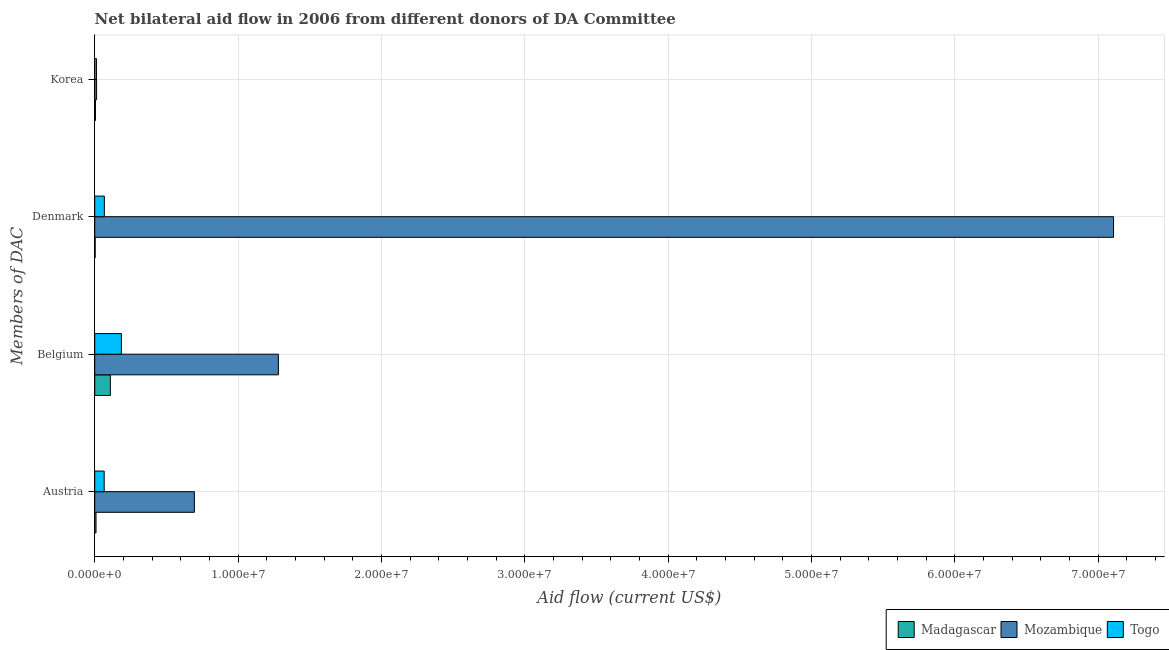How many groups of bars are there?
Offer a terse response. 4. Are the number of bars per tick equal to the number of legend labels?
Offer a terse response. Yes. Are the number of bars on each tick of the Y-axis equal?
Keep it short and to the point. Yes. How many bars are there on the 3rd tick from the bottom?
Offer a terse response. 3. What is the label of the 3rd group of bars from the top?
Make the answer very short. Belgium. What is the amount of aid given by belgium in Togo?
Give a very brief answer. 1.86e+06. Across all countries, what is the maximum amount of aid given by denmark?
Keep it short and to the point. 7.11e+07. Across all countries, what is the minimum amount of aid given by austria?
Keep it short and to the point. 9.00e+04. In which country was the amount of aid given by austria maximum?
Offer a terse response. Mozambique. In which country was the amount of aid given by belgium minimum?
Provide a succinct answer. Madagascar. What is the total amount of aid given by belgium in the graph?
Provide a short and direct response. 1.58e+07. What is the difference between the amount of aid given by belgium in Togo and that in Mozambique?
Ensure brevity in your answer.  -1.10e+07. What is the difference between the amount of aid given by austria in Togo and the amount of aid given by korea in Mozambique?
Your response must be concise. 5.30e+05. What is the average amount of aid given by belgium per country?
Provide a short and direct response. 5.25e+06. What is the difference between the amount of aid given by denmark and amount of aid given by austria in Togo?
Make the answer very short. 10000. In how many countries, is the amount of aid given by korea greater than 22000000 US$?
Make the answer very short. 0. What is the ratio of the amount of aid given by austria in Mozambique to that in Madagascar?
Your answer should be very brief. 77.22. Is the amount of aid given by austria in Mozambique less than that in Togo?
Provide a short and direct response. No. Is the difference between the amount of aid given by korea in Mozambique and Madagascar greater than the difference between the amount of aid given by belgium in Mozambique and Madagascar?
Offer a very short reply. No. What is the difference between the highest and the second highest amount of aid given by belgium?
Your response must be concise. 1.10e+07. What is the difference between the highest and the lowest amount of aid given by belgium?
Give a very brief answer. 1.17e+07. What does the 2nd bar from the top in Austria represents?
Your answer should be very brief. Mozambique. What does the 3rd bar from the bottom in Korea represents?
Give a very brief answer. Togo. Is it the case that in every country, the sum of the amount of aid given by austria and amount of aid given by belgium is greater than the amount of aid given by denmark?
Ensure brevity in your answer.  No. How many bars are there?
Make the answer very short. 12. How many countries are there in the graph?
Give a very brief answer. 3. What is the difference between two consecutive major ticks on the X-axis?
Give a very brief answer. 1.00e+07. How many legend labels are there?
Provide a short and direct response. 3. How are the legend labels stacked?
Make the answer very short. Horizontal. What is the title of the graph?
Your response must be concise. Net bilateral aid flow in 2006 from different donors of DA Committee. What is the label or title of the Y-axis?
Your answer should be compact. Members of DAC. What is the Aid flow (current US$) of Mozambique in Austria?
Make the answer very short. 6.95e+06. What is the Aid flow (current US$) in Madagascar in Belgium?
Provide a succinct answer. 1.09e+06. What is the Aid flow (current US$) of Mozambique in Belgium?
Your response must be concise. 1.28e+07. What is the Aid flow (current US$) of Togo in Belgium?
Keep it short and to the point. 1.86e+06. What is the Aid flow (current US$) in Mozambique in Denmark?
Give a very brief answer. 7.11e+07. What is the Aid flow (current US$) in Togo in Denmark?
Make the answer very short. 6.70e+05. What is the Aid flow (current US$) in Madagascar in Korea?
Give a very brief answer. 5.00e+04. What is the Aid flow (current US$) in Mozambique in Korea?
Give a very brief answer. 1.30e+05. What is the Aid flow (current US$) of Togo in Korea?
Offer a very short reply. 1.20e+05. Across all Members of DAC, what is the maximum Aid flow (current US$) in Madagascar?
Offer a very short reply. 1.09e+06. Across all Members of DAC, what is the maximum Aid flow (current US$) of Mozambique?
Provide a short and direct response. 7.11e+07. Across all Members of DAC, what is the maximum Aid flow (current US$) of Togo?
Provide a succinct answer. 1.86e+06. Across all Members of DAC, what is the minimum Aid flow (current US$) of Madagascar?
Provide a short and direct response. 3.00e+04. Across all Members of DAC, what is the minimum Aid flow (current US$) of Mozambique?
Ensure brevity in your answer.  1.30e+05. What is the total Aid flow (current US$) of Madagascar in the graph?
Offer a very short reply. 1.26e+06. What is the total Aid flow (current US$) in Mozambique in the graph?
Provide a short and direct response. 9.10e+07. What is the total Aid flow (current US$) in Togo in the graph?
Offer a terse response. 3.31e+06. What is the difference between the Aid flow (current US$) in Mozambique in Austria and that in Belgium?
Give a very brief answer. -5.86e+06. What is the difference between the Aid flow (current US$) in Togo in Austria and that in Belgium?
Provide a succinct answer. -1.20e+06. What is the difference between the Aid flow (current US$) of Madagascar in Austria and that in Denmark?
Your answer should be very brief. 6.00e+04. What is the difference between the Aid flow (current US$) of Mozambique in Austria and that in Denmark?
Your answer should be compact. -6.41e+07. What is the difference between the Aid flow (current US$) in Togo in Austria and that in Denmark?
Provide a succinct answer. -10000. What is the difference between the Aid flow (current US$) of Mozambique in Austria and that in Korea?
Your answer should be compact. 6.82e+06. What is the difference between the Aid flow (current US$) of Togo in Austria and that in Korea?
Provide a short and direct response. 5.40e+05. What is the difference between the Aid flow (current US$) in Madagascar in Belgium and that in Denmark?
Your answer should be compact. 1.06e+06. What is the difference between the Aid flow (current US$) of Mozambique in Belgium and that in Denmark?
Your answer should be compact. -5.83e+07. What is the difference between the Aid flow (current US$) in Togo in Belgium and that in Denmark?
Offer a terse response. 1.19e+06. What is the difference between the Aid flow (current US$) in Madagascar in Belgium and that in Korea?
Ensure brevity in your answer.  1.04e+06. What is the difference between the Aid flow (current US$) in Mozambique in Belgium and that in Korea?
Offer a very short reply. 1.27e+07. What is the difference between the Aid flow (current US$) in Togo in Belgium and that in Korea?
Provide a short and direct response. 1.74e+06. What is the difference between the Aid flow (current US$) of Madagascar in Denmark and that in Korea?
Provide a succinct answer. -2.00e+04. What is the difference between the Aid flow (current US$) of Mozambique in Denmark and that in Korea?
Provide a short and direct response. 7.09e+07. What is the difference between the Aid flow (current US$) of Madagascar in Austria and the Aid flow (current US$) of Mozambique in Belgium?
Keep it short and to the point. -1.27e+07. What is the difference between the Aid flow (current US$) in Madagascar in Austria and the Aid flow (current US$) in Togo in Belgium?
Keep it short and to the point. -1.77e+06. What is the difference between the Aid flow (current US$) in Mozambique in Austria and the Aid flow (current US$) in Togo in Belgium?
Provide a succinct answer. 5.09e+06. What is the difference between the Aid flow (current US$) of Madagascar in Austria and the Aid flow (current US$) of Mozambique in Denmark?
Make the answer very short. -7.10e+07. What is the difference between the Aid flow (current US$) of Madagascar in Austria and the Aid flow (current US$) of Togo in Denmark?
Ensure brevity in your answer.  -5.80e+05. What is the difference between the Aid flow (current US$) in Mozambique in Austria and the Aid flow (current US$) in Togo in Denmark?
Make the answer very short. 6.28e+06. What is the difference between the Aid flow (current US$) of Mozambique in Austria and the Aid flow (current US$) of Togo in Korea?
Give a very brief answer. 6.83e+06. What is the difference between the Aid flow (current US$) in Madagascar in Belgium and the Aid flow (current US$) in Mozambique in Denmark?
Give a very brief answer. -7.00e+07. What is the difference between the Aid flow (current US$) of Mozambique in Belgium and the Aid flow (current US$) of Togo in Denmark?
Keep it short and to the point. 1.21e+07. What is the difference between the Aid flow (current US$) of Madagascar in Belgium and the Aid flow (current US$) of Mozambique in Korea?
Offer a terse response. 9.60e+05. What is the difference between the Aid flow (current US$) of Madagascar in Belgium and the Aid flow (current US$) of Togo in Korea?
Keep it short and to the point. 9.70e+05. What is the difference between the Aid flow (current US$) of Mozambique in Belgium and the Aid flow (current US$) of Togo in Korea?
Make the answer very short. 1.27e+07. What is the difference between the Aid flow (current US$) in Madagascar in Denmark and the Aid flow (current US$) in Mozambique in Korea?
Make the answer very short. -1.00e+05. What is the difference between the Aid flow (current US$) of Mozambique in Denmark and the Aid flow (current US$) of Togo in Korea?
Give a very brief answer. 7.10e+07. What is the average Aid flow (current US$) of Madagascar per Members of DAC?
Provide a short and direct response. 3.15e+05. What is the average Aid flow (current US$) in Mozambique per Members of DAC?
Offer a terse response. 2.27e+07. What is the average Aid flow (current US$) of Togo per Members of DAC?
Offer a very short reply. 8.28e+05. What is the difference between the Aid flow (current US$) of Madagascar and Aid flow (current US$) of Mozambique in Austria?
Offer a very short reply. -6.86e+06. What is the difference between the Aid flow (current US$) of Madagascar and Aid flow (current US$) of Togo in Austria?
Your answer should be compact. -5.70e+05. What is the difference between the Aid flow (current US$) of Mozambique and Aid flow (current US$) of Togo in Austria?
Offer a very short reply. 6.29e+06. What is the difference between the Aid flow (current US$) of Madagascar and Aid flow (current US$) of Mozambique in Belgium?
Keep it short and to the point. -1.17e+07. What is the difference between the Aid flow (current US$) in Madagascar and Aid flow (current US$) in Togo in Belgium?
Give a very brief answer. -7.70e+05. What is the difference between the Aid flow (current US$) in Mozambique and Aid flow (current US$) in Togo in Belgium?
Your answer should be very brief. 1.10e+07. What is the difference between the Aid flow (current US$) in Madagascar and Aid flow (current US$) in Mozambique in Denmark?
Offer a terse response. -7.10e+07. What is the difference between the Aid flow (current US$) of Madagascar and Aid flow (current US$) of Togo in Denmark?
Offer a very short reply. -6.40e+05. What is the difference between the Aid flow (current US$) in Mozambique and Aid flow (current US$) in Togo in Denmark?
Provide a short and direct response. 7.04e+07. What is the difference between the Aid flow (current US$) in Madagascar and Aid flow (current US$) in Togo in Korea?
Provide a succinct answer. -7.00e+04. What is the difference between the Aid flow (current US$) in Mozambique and Aid flow (current US$) in Togo in Korea?
Your response must be concise. 10000. What is the ratio of the Aid flow (current US$) of Madagascar in Austria to that in Belgium?
Provide a succinct answer. 0.08. What is the ratio of the Aid flow (current US$) of Mozambique in Austria to that in Belgium?
Provide a succinct answer. 0.54. What is the ratio of the Aid flow (current US$) in Togo in Austria to that in Belgium?
Provide a short and direct response. 0.35. What is the ratio of the Aid flow (current US$) of Madagascar in Austria to that in Denmark?
Ensure brevity in your answer.  3. What is the ratio of the Aid flow (current US$) in Mozambique in Austria to that in Denmark?
Your response must be concise. 0.1. What is the ratio of the Aid flow (current US$) of Togo in Austria to that in Denmark?
Offer a terse response. 0.99. What is the ratio of the Aid flow (current US$) of Mozambique in Austria to that in Korea?
Your answer should be very brief. 53.46. What is the ratio of the Aid flow (current US$) of Togo in Austria to that in Korea?
Provide a succinct answer. 5.5. What is the ratio of the Aid flow (current US$) of Madagascar in Belgium to that in Denmark?
Keep it short and to the point. 36.33. What is the ratio of the Aid flow (current US$) of Mozambique in Belgium to that in Denmark?
Provide a succinct answer. 0.18. What is the ratio of the Aid flow (current US$) in Togo in Belgium to that in Denmark?
Provide a succinct answer. 2.78. What is the ratio of the Aid flow (current US$) in Madagascar in Belgium to that in Korea?
Your response must be concise. 21.8. What is the ratio of the Aid flow (current US$) in Mozambique in Belgium to that in Korea?
Keep it short and to the point. 98.54. What is the ratio of the Aid flow (current US$) of Madagascar in Denmark to that in Korea?
Your answer should be very brief. 0.6. What is the ratio of the Aid flow (current US$) of Mozambique in Denmark to that in Korea?
Provide a short and direct response. 546.69. What is the ratio of the Aid flow (current US$) in Togo in Denmark to that in Korea?
Your response must be concise. 5.58. What is the difference between the highest and the second highest Aid flow (current US$) of Madagascar?
Make the answer very short. 1.00e+06. What is the difference between the highest and the second highest Aid flow (current US$) of Mozambique?
Your answer should be compact. 5.83e+07. What is the difference between the highest and the second highest Aid flow (current US$) of Togo?
Your answer should be compact. 1.19e+06. What is the difference between the highest and the lowest Aid flow (current US$) of Madagascar?
Provide a short and direct response. 1.06e+06. What is the difference between the highest and the lowest Aid flow (current US$) in Mozambique?
Ensure brevity in your answer.  7.09e+07. What is the difference between the highest and the lowest Aid flow (current US$) in Togo?
Ensure brevity in your answer.  1.74e+06. 